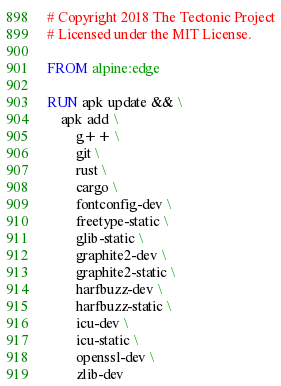Convert code to text. <code><loc_0><loc_0><loc_500><loc_500><_Dockerfile_># Copyright 2018 The Tectonic Project
# Licensed under the MIT License.

FROM alpine:edge

RUN apk update && \
    apk add \
        g++ \
        git \
        rust \
        cargo \
        fontconfig-dev \
        freetype-static \
        glib-static \
        graphite2-dev \
        graphite2-static \
        harfbuzz-dev \
        harfbuzz-static \
        icu-dev \
        icu-static \
        openssl-dev \
        zlib-dev
</code> 